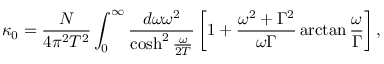<formula> <loc_0><loc_0><loc_500><loc_500>\kappa _ { 0 } = \frac { N } { 4 \pi ^ { 2 } T ^ { 2 } } \int _ { 0 } ^ { \infty } \frac { d \omega \omega ^ { 2 } } { \cosh ^ { 2 } \frac { \omega } { 2 T } } \left [ 1 + \frac { \omega ^ { 2 } + \Gamma ^ { 2 } } { \omega \Gamma } \arctan \frac { \omega } { \Gamma } \right ] ,</formula> 